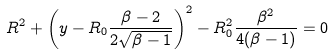<formula> <loc_0><loc_0><loc_500><loc_500>R ^ { 2 } + \left ( y - R _ { 0 } \frac { \beta - 2 } { 2 \sqrt { \beta - 1 } } \right ) ^ { 2 } - R _ { 0 } ^ { 2 } \frac { \beta ^ { 2 } } { 4 ( \beta - 1 ) } = 0</formula> 